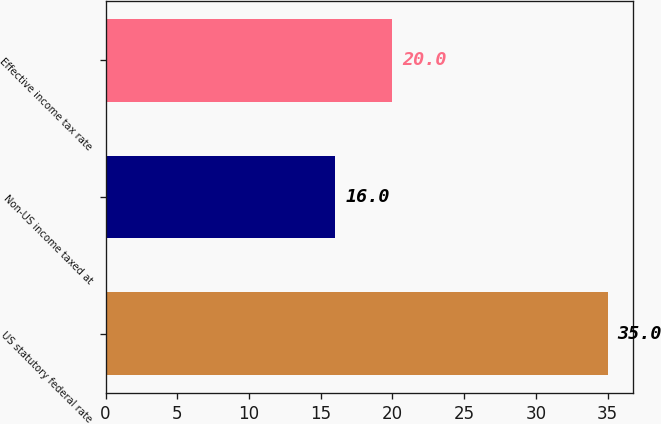<chart> <loc_0><loc_0><loc_500><loc_500><bar_chart><fcel>US statutory federal rate<fcel>Non-US income taxed at<fcel>Effective income tax rate<nl><fcel>35<fcel>16<fcel>20<nl></chart> 